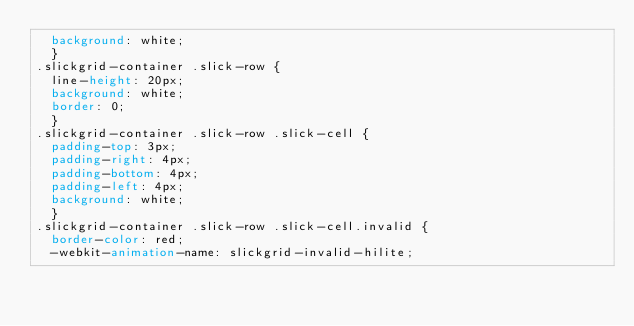Convert code to text. <code><loc_0><loc_0><loc_500><loc_500><_CSS_>  background: white;
  }
.slickgrid-container .slick-row {
  line-height: 20px;
  background: white;
  border: 0;
  }
.slickgrid-container .slick-row .slick-cell {
  padding-top: 3px;
  padding-right: 4px;
  padding-bottom: 4px;
  padding-left: 4px;
  background: white;
  }
.slickgrid-container .slick-row .slick-cell.invalid {
  border-color: red;
  -webkit-animation-name: slickgrid-invalid-hilite;</code> 